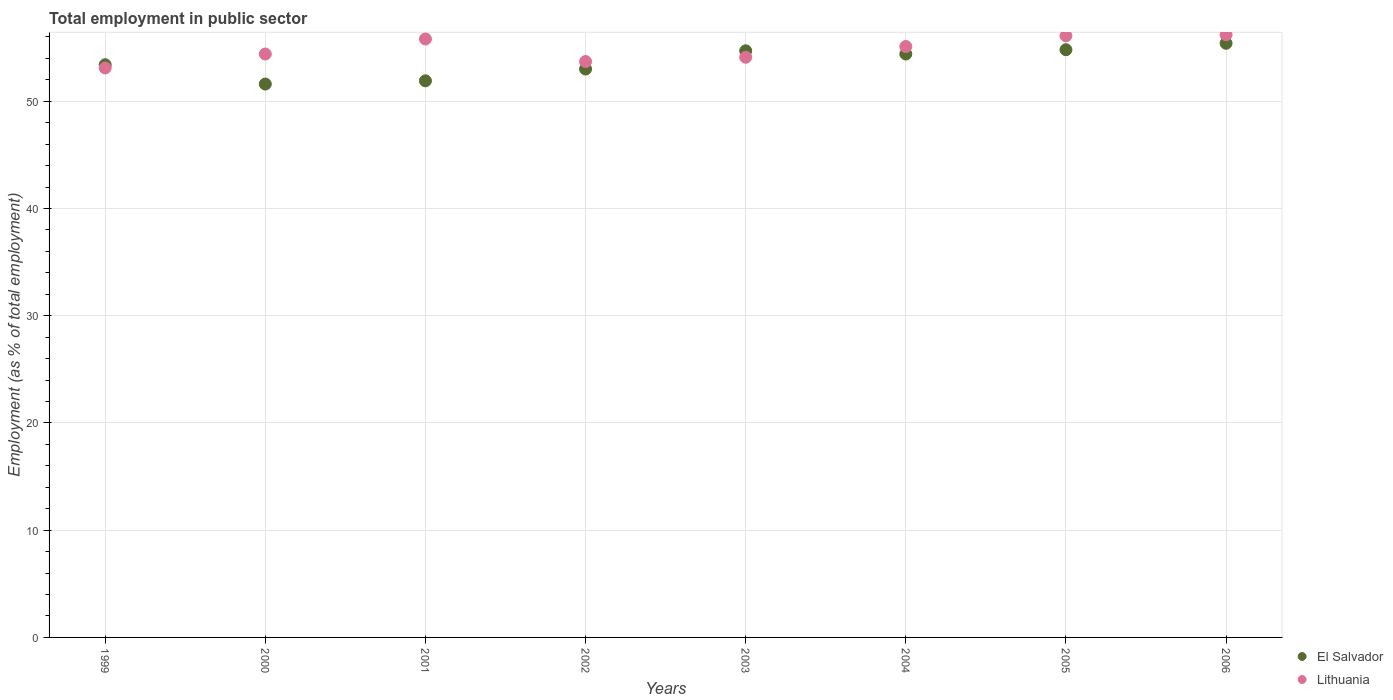Is the number of dotlines equal to the number of legend labels?
Offer a terse response. Yes. What is the employment in public sector in El Salvador in 1999?
Your answer should be compact. 53.4. Across all years, what is the maximum employment in public sector in Lithuania?
Offer a very short reply. 56.2. Across all years, what is the minimum employment in public sector in Lithuania?
Give a very brief answer. 53.1. In which year was the employment in public sector in Lithuania maximum?
Your response must be concise. 2006. What is the total employment in public sector in El Salvador in the graph?
Provide a succinct answer. 429.2. What is the difference between the employment in public sector in Lithuania in 1999 and that in 2005?
Make the answer very short. -3. What is the difference between the employment in public sector in Lithuania in 2004 and the employment in public sector in El Salvador in 2003?
Offer a very short reply. 0.4. What is the average employment in public sector in Lithuania per year?
Offer a terse response. 54.81. In the year 2001, what is the difference between the employment in public sector in El Salvador and employment in public sector in Lithuania?
Provide a short and direct response. -3.9. In how many years, is the employment in public sector in El Salvador greater than 36 %?
Your answer should be compact. 8. What is the ratio of the employment in public sector in El Salvador in 2004 to that in 2005?
Provide a succinct answer. 0.99. What is the difference between the highest and the second highest employment in public sector in Lithuania?
Offer a terse response. 0.1. What is the difference between the highest and the lowest employment in public sector in Lithuania?
Offer a terse response. 3.1. In how many years, is the employment in public sector in Lithuania greater than the average employment in public sector in Lithuania taken over all years?
Provide a succinct answer. 4. Does the employment in public sector in Lithuania monotonically increase over the years?
Offer a terse response. No. Is the employment in public sector in El Salvador strictly greater than the employment in public sector in Lithuania over the years?
Keep it short and to the point. No. Does the graph contain grids?
Make the answer very short. Yes. What is the title of the graph?
Give a very brief answer. Total employment in public sector. Does "Malaysia" appear as one of the legend labels in the graph?
Offer a terse response. No. What is the label or title of the Y-axis?
Provide a succinct answer. Employment (as % of total employment). What is the Employment (as % of total employment) in El Salvador in 1999?
Your response must be concise. 53.4. What is the Employment (as % of total employment) in Lithuania in 1999?
Your answer should be very brief. 53.1. What is the Employment (as % of total employment) in El Salvador in 2000?
Your response must be concise. 51.6. What is the Employment (as % of total employment) of Lithuania in 2000?
Ensure brevity in your answer.  54.4. What is the Employment (as % of total employment) in El Salvador in 2001?
Your answer should be compact. 51.9. What is the Employment (as % of total employment) in Lithuania in 2001?
Keep it short and to the point. 55.8. What is the Employment (as % of total employment) in Lithuania in 2002?
Provide a succinct answer. 53.7. What is the Employment (as % of total employment) in El Salvador in 2003?
Provide a short and direct response. 54.7. What is the Employment (as % of total employment) of Lithuania in 2003?
Keep it short and to the point. 54.1. What is the Employment (as % of total employment) in El Salvador in 2004?
Make the answer very short. 54.4. What is the Employment (as % of total employment) in Lithuania in 2004?
Provide a succinct answer. 55.1. What is the Employment (as % of total employment) in El Salvador in 2005?
Give a very brief answer. 54.8. What is the Employment (as % of total employment) of Lithuania in 2005?
Your answer should be very brief. 56.1. What is the Employment (as % of total employment) in El Salvador in 2006?
Provide a short and direct response. 55.4. What is the Employment (as % of total employment) of Lithuania in 2006?
Offer a terse response. 56.2. Across all years, what is the maximum Employment (as % of total employment) in El Salvador?
Ensure brevity in your answer.  55.4. Across all years, what is the maximum Employment (as % of total employment) of Lithuania?
Ensure brevity in your answer.  56.2. Across all years, what is the minimum Employment (as % of total employment) in El Salvador?
Your answer should be very brief. 51.6. Across all years, what is the minimum Employment (as % of total employment) in Lithuania?
Provide a short and direct response. 53.1. What is the total Employment (as % of total employment) of El Salvador in the graph?
Provide a succinct answer. 429.2. What is the total Employment (as % of total employment) in Lithuania in the graph?
Offer a very short reply. 438.5. What is the difference between the Employment (as % of total employment) in El Salvador in 1999 and that in 2000?
Offer a terse response. 1.8. What is the difference between the Employment (as % of total employment) of El Salvador in 1999 and that in 2001?
Offer a terse response. 1.5. What is the difference between the Employment (as % of total employment) in Lithuania in 1999 and that in 2001?
Provide a short and direct response. -2.7. What is the difference between the Employment (as % of total employment) in Lithuania in 1999 and that in 2002?
Give a very brief answer. -0.6. What is the difference between the Employment (as % of total employment) of El Salvador in 1999 and that in 2003?
Keep it short and to the point. -1.3. What is the difference between the Employment (as % of total employment) of Lithuania in 1999 and that in 2003?
Ensure brevity in your answer.  -1. What is the difference between the Employment (as % of total employment) in El Salvador in 1999 and that in 2004?
Make the answer very short. -1. What is the difference between the Employment (as % of total employment) of Lithuania in 1999 and that in 2004?
Ensure brevity in your answer.  -2. What is the difference between the Employment (as % of total employment) of El Salvador in 1999 and that in 2005?
Make the answer very short. -1.4. What is the difference between the Employment (as % of total employment) in Lithuania in 1999 and that in 2006?
Offer a very short reply. -3.1. What is the difference between the Employment (as % of total employment) in El Salvador in 2000 and that in 2001?
Your answer should be compact. -0.3. What is the difference between the Employment (as % of total employment) in Lithuania in 2000 and that in 2002?
Ensure brevity in your answer.  0.7. What is the difference between the Employment (as % of total employment) in El Salvador in 2000 and that in 2003?
Your answer should be compact. -3.1. What is the difference between the Employment (as % of total employment) in Lithuania in 2000 and that in 2003?
Ensure brevity in your answer.  0.3. What is the difference between the Employment (as % of total employment) of El Salvador in 2000 and that in 2004?
Offer a terse response. -2.8. What is the difference between the Employment (as % of total employment) in Lithuania in 2000 and that in 2004?
Provide a short and direct response. -0.7. What is the difference between the Employment (as % of total employment) in Lithuania in 2000 and that in 2006?
Offer a terse response. -1.8. What is the difference between the Employment (as % of total employment) of El Salvador in 2001 and that in 2002?
Give a very brief answer. -1.1. What is the difference between the Employment (as % of total employment) in El Salvador in 2001 and that in 2003?
Your answer should be compact. -2.8. What is the difference between the Employment (as % of total employment) of Lithuania in 2001 and that in 2003?
Your response must be concise. 1.7. What is the difference between the Employment (as % of total employment) in Lithuania in 2001 and that in 2004?
Provide a short and direct response. 0.7. What is the difference between the Employment (as % of total employment) of El Salvador in 2002 and that in 2003?
Offer a terse response. -1.7. What is the difference between the Employment (as % of total employment) in El Salvador in 2002 and that in 2004?
Ensure brevity in your answer.  -1.4. What is the difference between the Employment (as % of total employment) of Lithuania in 2002 and that in 2004?
Ensure brevity in your answer.  -1.4. What is the difference between the Employment (as % of total employment) in El Salvador in 2002 and that in 2005?
Your answer should be compact. -1.8. What is the difference between the Employment (as % of total employment) in Lithuania in 2002 and that in 2005?
Your answer should be very brief. -2.4. What is the difference between the Employment (as % of total employment) in El Salvador in 2002 and that in 2006?
Provide a succinct answer. -2.4. What is the difference between the Employment (as % of total employment) of Lithuania in 2002 and that in 2006?
Provide a short and direct response. -2.5. What is the difference between the Employment (as % of total employment) of El Salvador in 2003 and that in 2004?
Your response must be concise. 0.3. What is the difference between the Employment (as % of total employment) of El Salvador in 2003 and that in 2006?
Give a very brief answer. -0.7. What is the difference between the Employment (as % of total employment) in El Salvador in 2004 and that in 2006?
Make the answer very short. -1. What is the difference between the Employment (as % of total employment) in Lithuania in 2005 and that in 2006?
Provide a short and direct response. -0.1. What is the difference between the Employment (as % of total employment) in El Salvador in 1999 and the Employment (as % of total employment) in Lithuania in 2000?
Offer a terse response. -1. What is the difference between the Employment (as % of total employment) in El Salvador in 1999 and the Employment (as % of total employment) in Lithuania in 2005?
Make the answer very short. -2.7. What is the difference between the Employment (as % of total employment) in El Salvador in 2000 and the Employment (as % of total employment) in Lithuania in 2001?
Keep it short and to the point. -4.2. What is the difference between the Employment (as % of total employment) of El Salvador in 2000 and the Employment (as % of total employment) of Lithuania in 2002?
Provide a succinct answer. -2.1. What is the difference between the Employment (as % of total employment) in El Salvador in 2000 and the Employment (as % of total employment) in Lithuania in 2004?
Make the answer very short. -3.5. What is the difference between the Employment (as % of total employment) of El Salvador in 2000 and the Employment (as % of total employment) of Lithuania in 2005?
Offer a very short reply. -4.5. What is the difference between the Employment (as % of total employment) of El Salvador in 2001 and the Employment (as % of total employment) of Lithuania in 2003?
Ensure brevity in your answer.  -2.2. What is the difference between the Employment (as % of total employment) in El Salvador in 2001 and the Employment (as % of total employment) in Lithuania in 2006?
Offer a terse response. -4.3. What is the difference between the Employment (as % of total employment) of El Salvador in 2002 and the Employment (as % of total employment) of Lithuania in 2004?
Offer a terse response. -2.1. What is the difference between the Employment (as % of total employment) of El Salvador in 2002 and the Employment (as % of total employment) of Lithuania in 2006?
Offer a very short reply. -3.2. What is the difference between the Employment (as % of total employment) of El Salvador in 2005 and the Employment (as % of total employment) of Lithuania in 2006?
Keep it short and to the point. -1.4. What is the average Employment (as % of total employment) of El Salvador per year?
Provide a short and direct response. 53.65. What is the average Employment (as % of total employment) in Lithuania per year?
Your response must be concise. 54.81. In the year 1999, what is the difference between the Employment (as % of total employment) in El Salvador and Employment (as % of total employment) in Lithuania?
Make the answer very short. 0.3. In the year 2000, what is the difference between the Employment (as % of total employment) in El Salvador and Employment (as % of total employment) in Lithuania?
Make the answer very short. -2.8. In the year 2002, what is the difference between the Employment (as % of total employment) in El Salvador and Employment (as % of total employment) in Lithuania?
Your response must be concise. -0.7. In the year 2003, what is the difference between the Employment (as % of total employment) in El Salvador and Employment (as % of total employment) in Lithuania?
Offer a terse response. 0.6. In the year 2005, what is the difference between the Employment (as % of total employment) in El Salvador and Employment (as % of total employment) in Lithuania?
Offer a terse response. -1.3. In the year 2006, what is the difference between the Employment (as % of total employment) in El Salvador and Employment (as % of total employment) in Lithuania?
Ensure brevity in your answer.  -0.8. What is the ratio of the Employment (as % of total employment) in El Salvador in 1999 to that in 2000?
Provide a succinct answer. 1.03. What is the ratio of the Employment (as % of total employment) of Lithuania in 1999 to that in 2000?
Make the answer very short. 0.98. What is the ratio of the Employment (as % of total employment) in El Salvador in 1999 to that in 2001?
Provide a short and direct response. 1.03. What is the ratio of the Employment (as % of total employment) in Lithuania in 1999 to that in 2001?
Give a very brief answer. 0.95. What is the ratio of the Employment (as % of total employment) in El Salvador in 1999 to that in 2002?
Keep it short and to the point. 1.01. What is the ratio of the Employment (as % of total employment) of Lithuania in 1999 to that in 2002?
Make the answer very short. 0.99. What is the ratio of the Employment (as % of total employment) of El Salvador in 1999 to that in 2003?
Offer a very short reply. 0.98. What is the ratio of the Employment (as % of total employment) in Lithuania in 1999 to that in 2003?
Provide a succinct answer. 0.98. What is the ratio of the Employment (as % of total employment) in El Salvador in 1999 to that in 2004?
Ensure brevity in your answer.  0.98. What is the ratio of the Employment (as % of total employment) of Lithuania in 1999 to that in 2004?
Offer a very short reply. 0.96. What is the ratio of the Employment (as % of total employment) in El Salvador in 1999 to that in 2005?
Provide a short and direct response. 0.97. What is the ratio of the Employment (as % of total employment) in Lithuania in 1999 to that in 2005?
Offer a terse response. 0.95. What is the ratio of the Employment (as % of total employment) in El Salvador in 1999 to that in 2006?
Offer a terse response. 0.96. What is the ratio of the Employment (as % of total employment) in Lithuania in 1999 to that in 2006?
Your response must be concise. 0.94. What is the ratio of the Employment (as % of total employment) of Lithuania in 2000 to that in 2001?
Give a very brief answer. 0.97. What is the ratio of the Employment (as % of total employment) of El Salvador in 2000 to that in 2002?
Offer a very short reply. 0.97. What is the ratio of the Employment (as % of total employment) of El Salvador in 2000 to that in 2003?
Make the answer very short. 0.94. What is the ratio of the Employment (as % of total employment) of El Salvador in 2000 to that in 2004?
Provide a short and direct response. 0.95. What is the ratio of the Employment (as % of total employment) of Lithuania in 2000 to that in 2004?
Provide a succinct answer. 0.99. What is the ratio of the Employment (as % of total employment) in El Salvador in 2000 to that in 2005?
Give a very brief answer. 0.94. What is the ratio of the Employment (as % of total employment) of Lithuania in 2000 to that in 2005?
Your response must be concise. 0.97. What is the ratio of the Employment (as % of total employment) of El Salvador in 2000 to that in 2006?
Offer a terse response. 0.93. What is the ratio of the Employment (as % of total employment) in El Salvador in 2001 to that in 2002?
Give a very brief answer. 0.98. What is the ratio of the Employment (as % of total employment) in Lithuania in 2001 to that in 2002?
Give a very brief answer. 1.04. What is the ratio of the Employment (as % of total employment) in El Salvador in 2001 to that in 2003?
Make the answer very short. 0.95. What is the ratio of the Employment (as % of total employment) in Lithuania in 2001 to that in 2003?
Provide a short and direct response. 1.03. What is the ratio of the Employment (as % of total employment) in El Salvador in 2001 to that in 2004?
Your response must be concise. 0.95. What is the ratio of the Employment (as % of total employment) in Lithuania in 2001 to that in 2004?
Keep it short and to the point. 1.01. What is the ratio of the Employment (as % of total employment) of El Salvador in 2001 to that in 2005?
Your answer should be very brief. 0.95. What is the ratio of the Employment (as % of total employment) of El Salvador in 2001 to that in 2006?
Offer a very short reply. 0.94. What is the ratio of the Employment (as % of total employment) in El Salvador in 2002 to that in 2003?
Offer a very short reply. 0.97. What is the ratio of the Employment (as % of total employment) in El Salvador in 2002 to that in 2004?
Your answer should be compact. 0.97. What is the ratio of the Employment (as % of total employment) in Lithuania in 2002 to that in 2004?
Ensure brevity in your answer.  0.97. What is the ratio of the Employment (as % of total employment) of El Salvador in 2002 to that in 2005?
Keep it short and to the point. 0.97. What is the ratio of the Employment (as % of total employment) in Lithuania in 2002 to that in 2005?
Offer a terse response. 0.96. What is the ratio of the Employment (as % of total employment) of El Salvador in 2002 to that in 2006?
Offer a terse response. 0.96. What is the ratio of the Employment (as % of total employment) in Lithuania in 2002 to that in 2006?
Offer a very short reply. 0.96. What is the ratio of the Employment (as % of total employment) in El Salvador in 2003 to that in 2004?
Ensure brevity in your answer.  1.01. What is the ratio of the Employment (as % of total employment) in Lithuania in 2003 to that in 2004?
Make the answer very short. 0.98. What is the ratio of the Employment (as % of total employment) of El Salvador in 2003 to that in 2006?
Your answer should be very brief. 0.99. What is the ratio of the Employment (as % of total employment) of Lithuania in 2003 to that in 2006?
Your response must be concise. 0.96. What is the ratio of the Employment (as % of total employment) of Lithuania in 2004 to that in 2005?
Offer a terse response. 0.98. What is the ratio of the Employment (as % of total employment) of El Salvador in 2004 to that in 2006?
Provide a succinct answer. 0.98. What is the ratio of the Employment (as % of total employment) of Lithuania in 2004 to that in 2006?
Your response must be concise. 0.98. What is the ratio of the Employment (as % of total employment) in El Salvador in 2005 to that in 2006?
Give a very brief answer. 0.99. What is the difference between the highest and the second highest Employment (as % of total employment) of El Salvador?
Your answer should be compact. 0.6. What is the difference between the highest and the second highest Employment (as % of total employment) of Lithuania?
Make the answer very short. 0.1. What is the difference between the highest and the lowest Employment (as % of total employment) of Lithuania?
Keep it short and to the point. 3.1. 